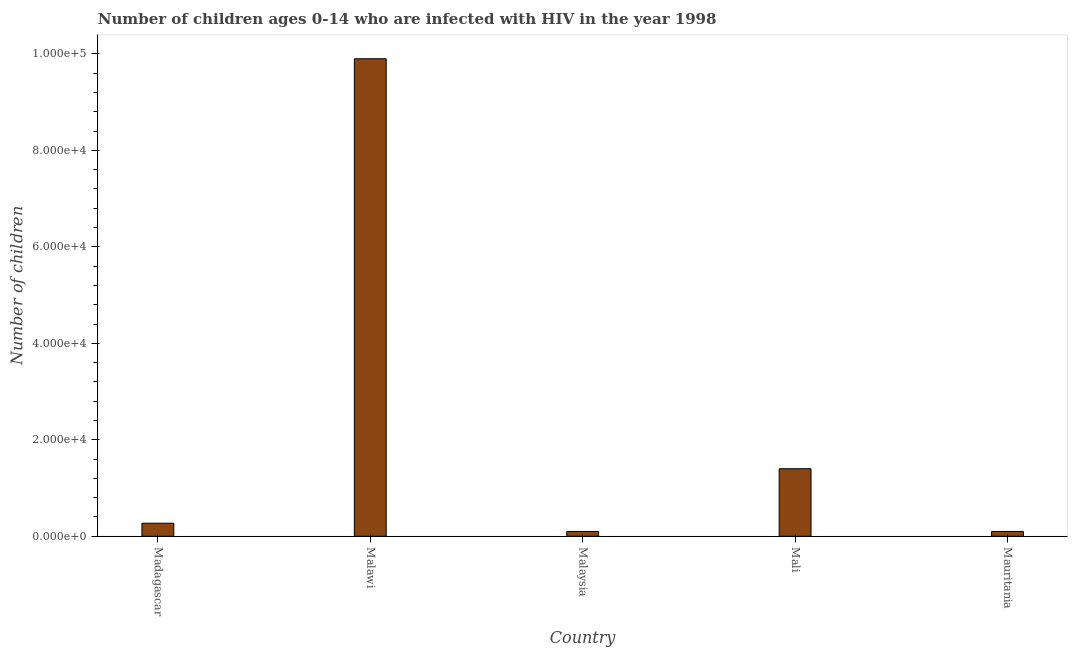What is the title of the graph?
Ensure brevity in your answer.  Number of children ages 0-14 who are infected with HIV in the year 1998. What is the label or title of the Y-axis?
Your answer should be very brief. Number of children. What is the number of children living with hiv in Malaysia?
Give a very brief answer. 1000. Across all countries, what is the maximum number of children living with hiv?
Provide a succinct answer. 9.90e+04. In which country was the number of children living with hiv maximum?
Make the answer very short. Malawi. In which country was the number of children living with hiv minimum?
Make the answer very short. Malaysia. What is the sum of the number of children living with hiv?
Make the answer very short. 1.18e+05. What is the difference between the number of children living with hiv in Madagascar and Malawi?
Keep it short and to the point. -9.63e+04. What is the average number of children living with hiv per country?
Offer a terse response. 2.35e+04. What is the median number of children living with hiv?
Your answer should be very brief. 2700. What is the ratio of the number of children living with hiv in Malawi to that in Mauritania?
Offer a terse response. 99. Is the difference between the number of children living with hiv in Malawi and Mauritania greater than the difference between any two countries?
Offer a terse response. Yes. What is the difference between the highest and the second highest number of children living with hiv?
Offer a terse response. 8.50e+04. Is the sum of the number of children living with hiv in Mali and Mauritania greater than the maximum number of children living with hiv across all countries?
Make the answer very short. No. What is the difference between the highest and the lowest number of children living with hiv?
Provide a succinct answer. 9.80e+04. How many countries are there in the graph?
Give a very brief answer. 5. What is the difference between two consecutive major ticks on the Y-axis?
Ensure brevity in your answer.  2.00e+04. Are the values on the major ticks of Y-axis written in scientific E-notation?
Keep it short and to the point. Yes. What is the Number of children in Madagascar?
Offer a terse response. 2700. What is the Number of children of Malawi?
Give a very brief answer. 9.90e+04. What is the Number of children in Malaysia?
Make the answer very short. 1000. What is the Number of children of Mali?
Ensure brevity in your answer.  1.40e+04. What is the difference between the Number of children in Madagascar and Malawi?
Keep it short and to the point. -9.63e+04. What is the difference between the Number of children in Madagascar and Malaysia?
Make the answer very short. 1700. What is the difference between the Number of children in Madagascar and Mali?
Provide a short and direct response. -1.13e+04. What is the difference between the Number of children in Madagascar and Mauritania?
Offer a terse response. 1700. What is the difference between the Number of children in Malawi and Malaysia?
Offer a very short reply. 9.80e+04. What is the difference between the Number of children in Malawi and Mali?
Offer a very short reply. 8.50e+04. What is the difference between the Number of children in Malawi and Mauritania?
Your response must be concise. 9.80e+04. What is the difference between the Number of children in Malaysia and Mali?
Ensure brevity in your answer.  -1.30e+04. What is the difference between the Number of children in Mali and Mauritania?
Ensure brevity in your answer.  1.30e+04. What is the ratio of the Number of children in Madagascar to that in Malawi?
Your response must be concise. 0.03. What is the ratio of the Number of children in Madagascar to that in Mali?
Keep it short and to the point. 0.19. What is the ratio of the Number of children in Madagascar to that in Mauritania?
Offer a very short reply. 2.7. What is the ratio of the Number of children in Malawi to that in Malaysia?
Provide a short and direct response. 99. What is the ratio of the Number of children in Malawi to that in Mali?
Provide a succinct answer. 7.07. What is the ratio of the Number of children in Malawi to that in Mauritania?
Your response must be concise. 99. What is the ratio of the Number of children in Malaysia to that in Mali?
Provide a succinct answer. 0.07. What is the ratio of the Number of children in Malaysia to that in Mauritania?
Offer a very short reply. 1. What is the ratio of the Number of children in Mali to that in Mauritania?
Your answer should be very brief. 14. 